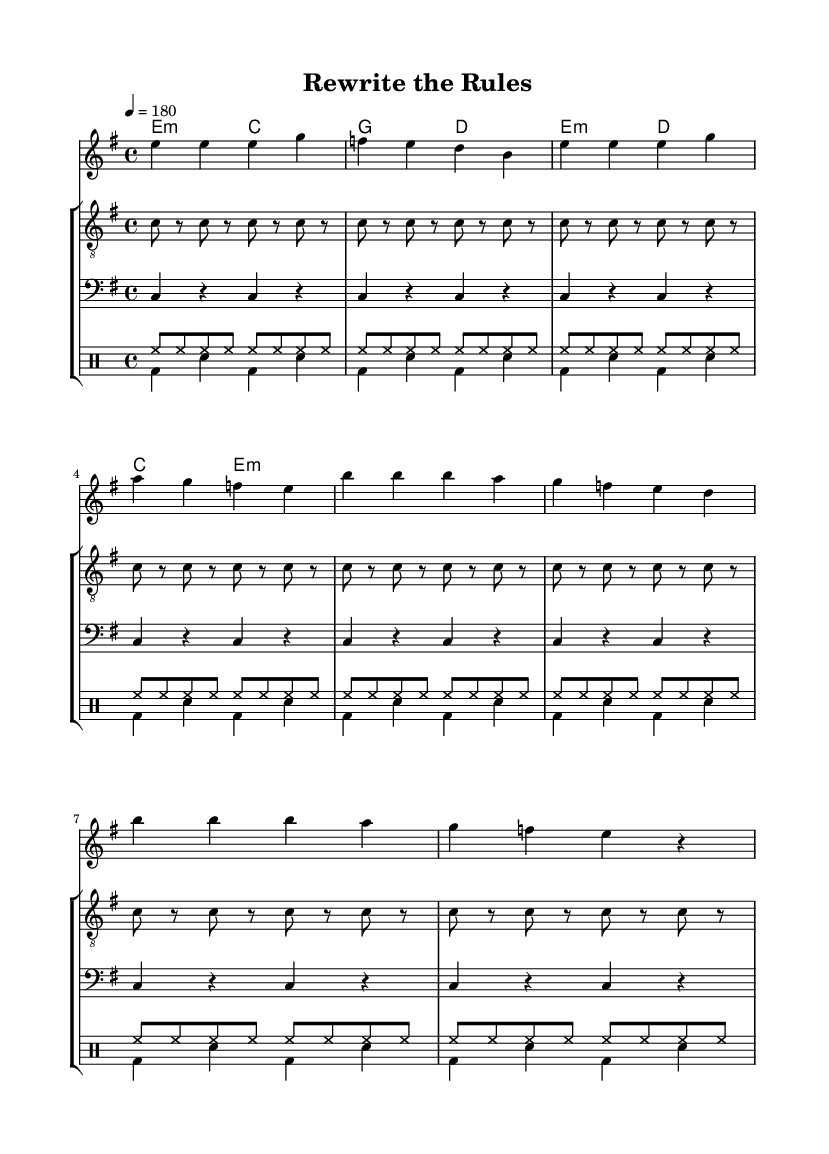What is the key signature of this music? The key signature is indicated by the placement of the sharp or flat symbols at the beginning of the staff. In this sheet music, it shows one sharp, which corresponds to E minor.
Answer: E minor What is the time signature of this music? The time signature is represented by the two numbers at the beginning of the staff. In this case, it shows 4/4, meaning there are four beats in each measure and a quarter note receives one beat.
Answer: 4/4 What is the tempo marking for this piece? The tempo is indicated at the beginning of the score, showing the phrase "4 = 180," which indicates that there are 180 beats per minute.
Answer: 180 How many measures are in the verse section of the score? The verse section is denoted by its melodic line and ends before the chorus begins. Counting the measures listed for the verse, we see there are four measures.
Answer: 4 Which chord is played in the first measure? The chords are listed under the staff and indicate which chords correspond to each measure. The first measure shows "e minor," indicating that e minor is played there.
Answer: e minor What type of music is represented in this score? The style of music can be inferred from the title, lyrics, and characteristics of the chords and tempo, which all align with punk themes, focusing on rebellion and breaking norms.
Answer: Punk What is the overall theme of the lyrics? The lyrics convey a message of rebellion against traditional narratives, highlighting a desire to disrupt typical storytelling and express individuality, which is a common punk theme.
Answer: Rebellion 